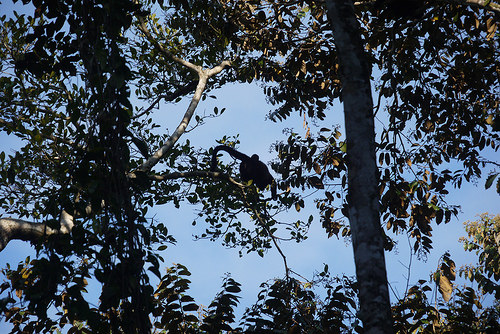<image>
Is the monkey on the tree? Yes. Looking at the image, I can see the monkey is positioned on top of the tree, with the tree providing support. Is there a right angle to the right of the bird shadow? No. The right angle is not to the right of the bird shadow. The horizontal positioning shows a different relationship. 